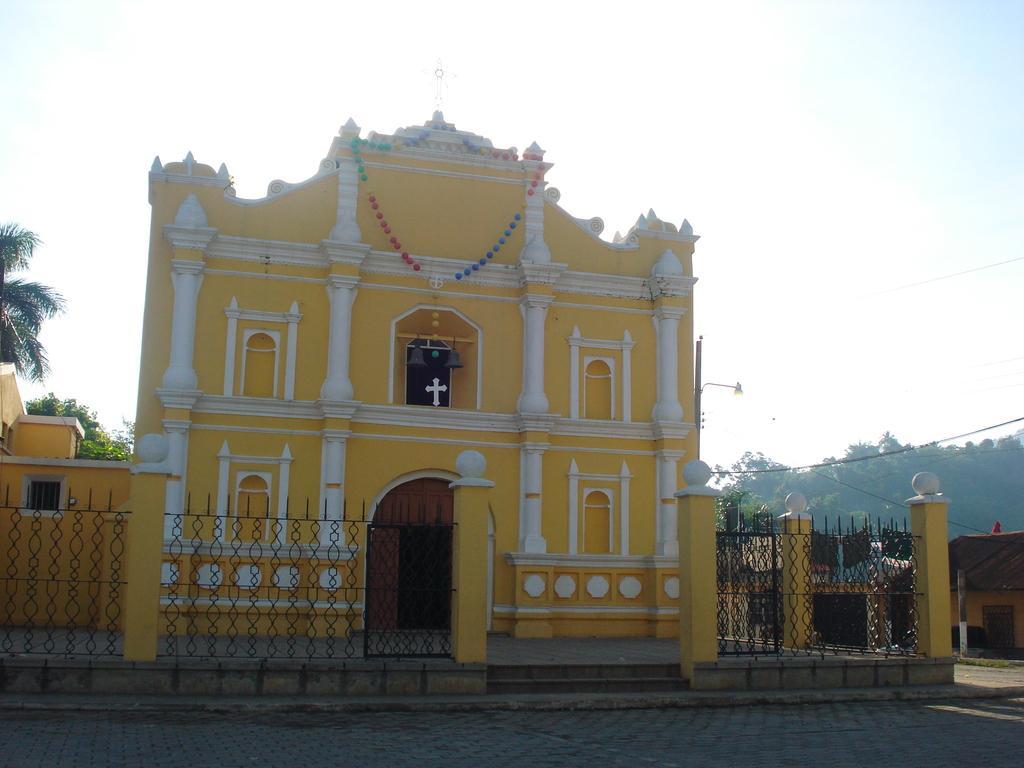How would you summarize this image in a sentence or two? In this image we can see a church, on the church we can see a cross symbol, there are some trees, fence, pillars and houses, in the background we can see the sky. 